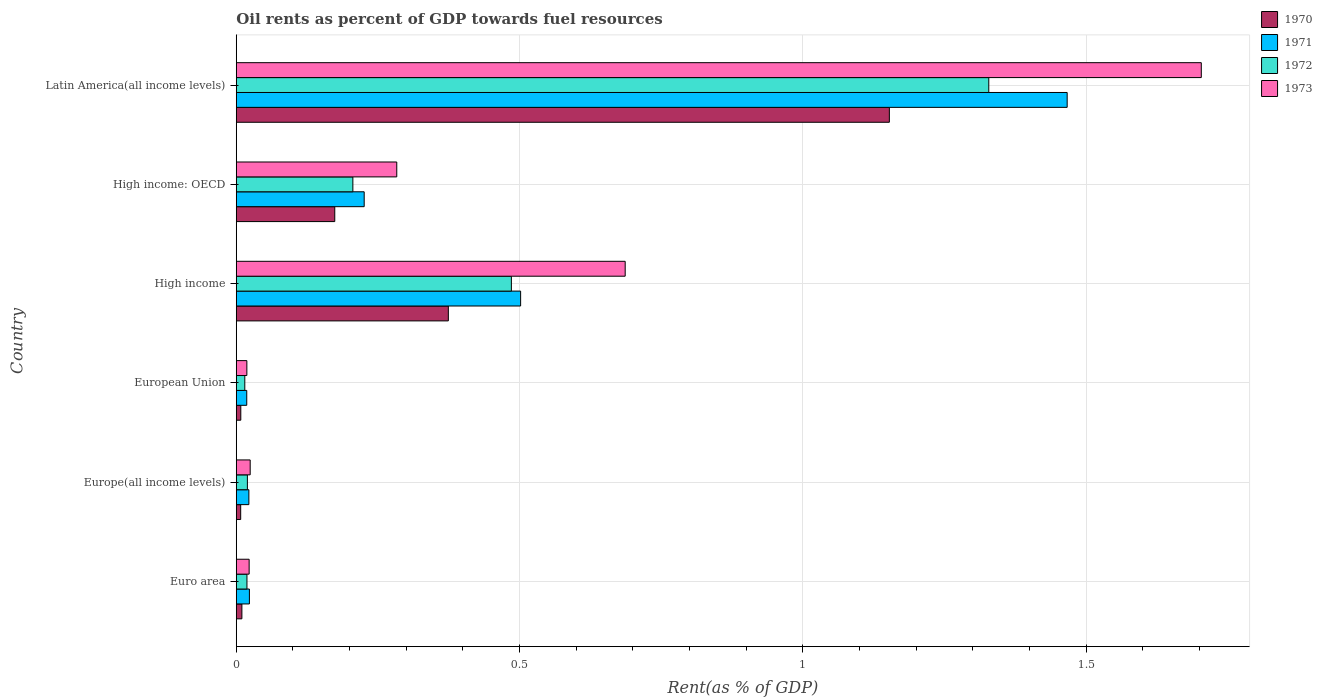Are the number of bars per tick equal to the number of legend labels?
Provide a succinct answer. Yes. How many bars are there on the 1st tick from the bottom?
Offer a terse response. 4. What is the oil rent in 1972 in High income: OECD?
Offer a terse response. 0.21. Across all countries, what is the maximum oil rent in 1971?
Make the answer very short. 1.47. Across all countries, what is the minimum oil rent in 1970?
Ensure brevity in your answer.  0.01. In which country was the oil rent in 1973 maximum?
Give a very brief answer. Latin America(all income levels). In which country was the oil rent in 1971 minimum?
Your answer should be very brief. European Union. What is the total oil rent in 1972 in the graph?
Make the answer very short. 2.07. What is the difference between the oil rent in 1971 in Euro area and that in European Union?
Your response must be concise. 0. What is the difference between the oil rent in 1972 in Euro area and the oil rent in 1971 in High income?
Make the answer very short. -0.48. What is the average oil rent in 1973 per country?
Give a very brief answer. 0.46. What is the difference between the oil rent in 1972 and oil rent in 1970 in High income: OECD?
Make the answer very short. 0.03. What is the ratio of the oil rent in 1971 in High income: OECD to that in Latin America(all income levels)?
Ensure brevity in your answer.  0.15. Is the difference between the oil rent in 1972 in Europe(all income levels) and High income: OECD greater than the difference between the oil rent in 1970 in Europe(all income levels) and High income: OECD?
Give a very brief answer. No. What is the difference between the highest and the second highest oil rent in 1971?
Provide a short and direct response. 0.96. What is the difference between the highest and the lowest oil rent in 1972?
Give a very brief answer. 1.31. Is it the case that in every country, the sum of the oil rent in 1970 and oil rent in 1973 is greater than the sum of oil rent in 1971 and oil rent in 1972?
Ensure brevity in your answer.  No. What does the 3rd bar from the bottom in Latin America(all income levels) represents?
Your answer should be compact. 1972. How many bars are there?
Offer a very short reply. 24. Are all the bars in the graph horizontal?
Your response must be concise. Yes. Are the values on the major ticks of X-axis written in scientific E-notation?
Make the answer very short. No. How many legend labels are there?
Your answer should be very brief. 4. How are the legend labels stacked?
Give a very brief answer. Vertical. What is the title of the graph?
Your answer should be very brief. Oil rents as percent of GDP towards fuel resources. Does "2006" appear as one of the legend labels in the graph?
Ensure brevity in your answer.  No. What is the label or title of the X-axis?
Provide a succinct answer. Rent(as % of GDP). What is the Rent(as % of GDP) of 1970 in Euro area?
Your answer should be compact. 0.01. What is the Rent(as % of GDP) in 1971 in Euro area?
Ensure brevity in your answer.  0.02. What is the Rent(as % of GDP) of 1972 in Euro area?
Make the answer very short. 0.02. What is the Rent(as % of GDP) in 1973 in Euro area?
Your response must be concise. 0.02. What is the Rent(as % of GDP) of 1970 in Europe(all income levels)?
Your answer should be very brief. 0.01. What is the Rent(as % of GDP) in 1971 in Europe(all income levels)?
Provide a succinct answer. 0.02. What is the Rent(as % of GDP) of 1972 in Europe(all income levels)?
Your answer should be compact. 0.02. What is the Rent(as % of GDP) in 1973 in Europe(all income levels)?
Your response must be concise. 0.02. What is the Rent(as % of GDP) of 1970 in European Union?
Ensure brevity in your answer.  0.01. What is the Rent(as % of GDP) of 1971 in European Union?
Give a very brief answer. 0.02. What is the Rent(as % of GDP) of 1972 in European Union?
Offer a very short reply. 0.02. What is the Rent(as % of GDP) in 1973 in European Union?
Your answer should be very brief. 0.02. What is the Rent(as % of GDP) of 1970 in High income?
Offer a very short reply. 0.37. What is the Rent(as % of GDP) of 1971 in High income?
Offer a terse response. 0.5. What is the Rent(as % of GDP) of 1972 in High income?
Ensure brevity in your answer.  0.49. What is the Rent(as % of GDP) of 1973 in High income?
Provide a succinct answer. 0.69. What is the Rent(as % of GDP) in 1970 in High income: OECD?
Offer a very short reply. 0.17. What is the Rent(as % of GDP) of 1971 in High income: OECD?
Your answer should be very brief. 0.23. What is the Rent(as % of GDP) in 1972 in High income: OECD?
Offer a terse response. 0.21. What is the Rent(as % of GDP) of 1973 in High income: OECD?
Your answer should be very brief. 0.28. What is the Rent(as % of GDP) in 1970 in Latin America(all income levels)?
Your answer should be very brief. 1.15. What is the Rent(as % of GDP) in 1971 in Latin America(all income levels)?
Keep it short and to the point. 1.47. What is the Rent(as % of GDP) of 1972 in Latin America(all income levels)?
Make the answer very short. 1.33. What is the Rent(as % of GDP) of 1973 in Latin America(all income levels)?
Keep it short and to the point. 1.7. Across all countries, what is the maximum Rent(as % of GDP) in 1970?
Offer a very short reply. 1.15. Across all countries, what is the maximum Rent(as % of GDP) in 1971?
Your answer should be compact. 1.47. Across all countries, what is the maximum Rent(as % of GDP) in 1972?
Keep it short and to the point. 1.33. Across all countries, what is the maximum Rent(as % of GDP) in 1973?
Your response must be concise. 1.7. Across all countries, what is the minimum Rent(as % of GDP) in 1970?
Your answer should be compact. 0.01. Across all countries, what is the minimum Rent(as % of GDP) of 1971?
Keep it short and to the point. 0.02. Across all countries, what is the minimum Rent(as % of GDP) in 1972?
Offer a terse response. 0.02. Across all countries, what is the minimum Rent(as % of GDP) in 1973?
Offer a very short reply. 0.02. What is the total Rent(as % of GDP) of 1970 in the graph?
Offer a terse response. 1.73. What is the total Rent(as % of GDP) of 1971 in the graph?
Provide a succinct answer. 2.26. What is the total Rent(as % of GDP) of 1972 in the graph?
Offer a very short reply. 2.07. What is the total Rent(as % of GDP) of 1973 in the graph?
Offer a terse response. 2.74. What is the difference between the Rent(as % of GDP) in 1970 in Euro area and that in Europe(all income levels)?
Ensure brevity in your answer.  0. What is the difference between the Rent(as % of GDP) of 1971 in Euro area and that in Europe(all income levels)?
Provide a short and direct response. 0. What is the difference between the Rent(as % of GDP) of 1972 in Euro area and that in Europe(all income levels)?
Give a very brief answer. -0. What is the difference between the Rent(as % of GDP) in 1973 in Euro area and that in Europe(all income levels)?
Offer a terse response. -0. What is the difference between the Rent(as % of GDP) in 1970 in Euro area and that in European Union?
Provide a short and direct response. 0. What is the difference between the Rent(as % of GDP) in 1971 in Euro area and that in European Union?
Give a very brief answer. 0. What is the difference between the Rent(as % of GDP) in 1972 in Euro area and that in European Union?
Offer a very short reply. 0. What is the difference between the Rent(as % of GDP) in 1973 in Euro area and that in European Union?
Provide a succinct answer. 0. What is the difference between the Rent(as % of GDP) of 1970 in Euro area and that in High income?
Provide a short and direct response. -0.36. What is the difference between the Rent(as % of GDP) in 1971 in Euro area and that in High income?
Your answer should be very brief. -0.48. What is the difference between the Rent(as % of GDP) of 1972 in Euro area and that in High income?
Your answer should be very brief. -0.47. What is the difference between the Rent(as % of GDP) of 1973 in Euro area and that in High income?
Your answer should be very brief. -0.66. What is the difference between the Rent(as % of GDP) in 1970 in Euro area and that in High income: OECD?
Provide a succinct answer. -0.16. What is the difference between the Rent(as % of GDP) in 1971 in Euro area and that in High income: OECD?
Offer a very short reply. -0.2. What is the difference between the Rent(as % of GDP) of 1972 in Euro area and that in High income: OECD?
Make the answer very short. -0.19. What is the difference between the Rent(as % of GDP) of 1973 in Euro area and that in High income: OECD?
Your answer should be compact. -0.26. What is the difference between the Rent(as % of GDP) in 1970 in Euro area and that in Latin America(all income levels)?
Offer a very short reply. -1.14. What is the difference between the Rent(as % of GDP) of 1971 in Euro area and that in Latin America(all income levels)?
Ensure brevity in your answer.  -1.44. What is the difference between the Rent(as % of GDP) of 1972 in Euro area and that in Latin America(all income levels)?
Your answer should be compact. -1.31. What is the difference between the Rent(as % of GDP) of 1973 in Euro area and that in Latin America(all income levels)?
Offer a terse response. -1.68. What is the difference between the Rent(as % of GDP) in 1970 in Europe(all income levels) and that in European Union?
Offer a very short reply. -0. What is the difference between the Rent(as % of GDP) in 1971 in Europe(all income levels) and that in European Union?
Offer a terse response. 0. What is the difference between the Rent(as % of GDP) of 1972 in Europe(all income levels) and that in European Union?
Make the answer very short. 0. What is the difference between the Rent(as % of GDP) in 1973 in Europe(all income levels) and that in European Union?
Your answer should be compact. 0.01. What is the difference between the Rent(as % of GDP) in 1970 in Europe(all income levels) and that in High income?
Make the answer very short. -0.37. What is the difference between the Rent(as % of GDP) of 1971 in Europe(all income levels) and that in High income?
Offer a terse response. -0.48. What is the difference between the Rent(as % of GDP) of 1972 in Europe(all income levels) and that in High income?
Your answer should be compact. -0.47. What is the difference between the Rent(as % of GDP) in 1973 in Europe(all income levels) and that in High income?
Your answer should be very brief. -0.66. What is the difference between the Rent(as % of GDP) in 1970 in Europe(all income levels) and that in High income: OECD?
Keep it short and to the point. -0.17. What is the difference between the Rent(as % of GDP) in 1971 in Europe(all income levels) and that in High income: OECD?
Make the answer very short. -0.2. What is the difference between the Rent(as % of GDP) in 1972 in Europe(all income levels) and that in High income: OECD?
Make the answer very short. -0.19. What is the difference between the Rent(as % of GDP) in 1973 in Europe(all income levels) and that in High income: OECD?
Ensure brevity in your answer.  -0.26. What is the difference between the Rent(as % of GDP) of 1970 in Europe(all income levels) and that in Latin America(all income levels)?
Your answer should be very brief. -1.14. What is the difference between the Rent(as % of GDP) in 1971 in Europe(all income levels) and that in Latin America(all income levels)?
Your answer should be compact. -1.44. What is the difference between the Rent(as % of GDP) of 1972 in Europe(all income levels) and that in Latin America(all income levels)?
Offer a terse response. -1.31. What is the difference between the Rent(as % of GDP) in 1973 in Europe(all income levels) and that in Latin America(all income levels)?
Your answer should be very brief. -1.68. What is the difference between the Rent(as % of GDP) of 1970 in European Union and that in High income?
Offer a terse response. -0.37. What is the difference between the Rent(as % of GDP) in 1971 in European Union and that in High income?
Provide a short and direct response. -0.48. What is the difference between the Rent(as % of GDP) in 1972 in European Union and that in High income?
Ensure brevity in your answer.  -0.47. What is the difference between the Rent(as % of GDP) of 1973 in European Union and that in High income?
Make the answer very short. -0.67. What is the difference between the Rent(as % of GDP) in 1970 in European Union and that in High income: OECD?
Your response must be concise. -0.17. What is the difference between the Rent(as % of GDP) in 1971 in European Union and that in High income: OECD?
Make the answer very short. -0.21. What is the difference between the Rent(as % of GDP) in 1972 in European Union and that in High income: OECD?
Ensure brevity in your answer.  -0.19. What is the difference between the Rent(as % of GDP) of 1973 in European Union and that in High income: OECD?
Your answer should be very brief. -0.26. What is the difference between the Rent(as % of GDP) in 1970 in European Union and that in Latin America(all income levels)?
Ensure brevity in your answer.  -1.14. What is the difference between the Rent(as % of GDP) in 1971 in European Union and that in Latin America(all income levels)?
Your response must be concise. -1.45. What is the difference between the Rent(as % of GDP) in 1972 in European Union and that in Latin America(all income levels)?
Make the answer very short. -1.31. What is the difference between the Rent(as % of GDP) in 1973 in European Union and that in Latin America(all income levels)?
Your answer should be very brief. -1.68. What is the difference between the Rent(as % of GDP) of 1970 in High income and that in High income: OECD?
Offer a very short reply. 0.2. What is the difference between the Rent(as % of GDP) of 1971 in High income and that in High income: OECD?
Your answer should be compact. 0.28. What is the difference between the Rent(as % of GDP) in 1972 in High income and that in High income: OECD?
Offer a terse response. 0.28. What is the difference between the Rent(as % of GDP) of 1973 in High income and that in High income: OECD?
Your answer should be compact. 0.4. What is the difference between the Rent(as % of GDP) of 1970 in High income and that in Latin America(all income levels)?
Offer a very short reply. -0.78. What is the difference between the Rent(as % of GDP) of 1971 in High income and that in Latin America(all income levels)?
Offer a terse response. -0.96. What is the difference between the Rent(as % of GDP) in 1972 in High income and that in Latin America(all income levels)?
Give a very brief answer. -0.84. What is the difference between the Rent(as % of GDP) in 1973 in High income and that in Latin America(all income levels)?
Offer a very short reply. -1.02. What is the difference between the Rent(as % of GDP) in 1970 in High income: OECD and that in Latin America(all income levels)?
Offer a very short reply. -0.98. What is the difference between the Rent(as % of GDP) in 1971 in High income: OECD and that in Latin America(all income levels)?
Offer a very short reply. -1.24. What is the difference between the Rent(as % of GDP) of 1972 in High income: OECD and that in Latin America(all income levels)?
Make the answer very short. -1.12. What is the difference between the Rent(as % of GDP) in 1973 in High income: OECD and that in Latin America(all income levels)?
Offer a very short reply. -1.42. What is the difference between the Rent(as % of GDP) of 1970 in Euro area and the Rent(as % of GDP) of 1971 in Europe(all income levels)?
Offer a very short reply. -0.01. What is the difference between the Rent(as % of GDP) in 1970 in Euro area and the Rent(as % of GDP) in 1972 in Europe(all income levels)?
Offer a very short reply. -0.01. What is the difference between the Rent(as % of GDP) in 1970 in Euro area and the Rent(as % of GDP) in 1973 in Europe(all income levels)?
Your answer should be compact. -0.01. What is the difference between the Rent(as % of GDP) in 1971 in Euro area and the Rent(as % of GDP) in 1972 in Europe(all income levels)?
Your response must be concise. 0. What is the difference between the Rent(as % of GDP) of 1971 in Euro area and the Rent(as % of GDP) of 1973 in Europe(all income levels)?
Offer a terse response. -0. What is the difference between the Rent(as % of GDP) of 1972 in Euro area and the Rent(as % of GDP) of 1973 in Europe(all income levels)?
Offer a very short reply. -0.01. What is the difference between the Rent(as % of GDP) in 1970 in Euro area and the Rent(as % of GDP) in 1971 in European Union?
Offer a very short reply. -0.01. What is the difference between the Rent(as % of GDP) of 1970 in Euro area and the Rent(as % of GDP) of 1972 in European Union?
Make the answer very short. -0.01. What is the difference between the Rent(as % of GDP) of 1970 in Euro area and the Rent(as % of GDP) of 1973 in European Union?
Your response must be concise. -0.01. What is the difference between the Rent(as % of GDP) in 1971 in Euro area and the Rent(as % of GDP) in 1972 in European Union?
Your response must be concise. 0.01. What is the difference between the Rent(as % of GDP) of 1971 in Euro area and the Rent(as % of GDP) of 1973 in European Union?
Offer a very short reply. 0. What is the difference between the Rent(as % of GDP) in 1970 in Euro area and the Rent(as % of GDP) in 1971 in High income?
Your answer should be very brief. -0.49. What is the difference between the Rent(as % of GDP) of 1970 in Euro area and the Rent(as % of GDP) of 1972 in High income?
Your response must be concise. -0.48. What is the difference between the Rent(as % of GDP) in 1970 in Euro area and the Rent(as % of GDP) in 1973 in High income?
Keep it short and to the point. -0.68. What is the difference between the Rent(as % of GDP) of 1971 in Euro area and the Rent(as % of GDP) of 1972 in High income?
Your response must be concise. -0.46. What is the difference between the Rent(as % of GDP) of 1971 in Euro area and the Rent(as % of GDP) of 1973 in High income?
Your response must be concise. -0.66. What is the difference between the Rent(as % of GDP) in 1972 in Euro area and the Rent(as % of GDP) in 1973 in High income?
Give a very brief answer. -0.67. What is the difference between the Rent(as % of GDP) of 1970 in Euro area and the Rent(as % of GDP) of 1971 in High income: OECD?
Offer a very short reply. -0.22. What is the difference between the Rent(as % of GDP) of 1970 in Euro area and the Rent(as % of GDP) of 1972 in High income: OECD?
Offer a terse response. -0.2. What is the difference between the Rent(as % of GDP) of 1970 in Euro area and the Rent(as % of GDP) of 1973 in High income: OECD?
Make the answer very short. -0.27. What is the difference between the Rent(as % of GDP) in 1971 in Euro area and the Rent(as % of GDP) in 1972 in High income: OECD?
Your answer should be very brief. -0.18. What is the difference between the Rent(as % of GDP) of 1971 in Euro area and the Rent(as % of GDP) of 1973 in High income: OECD?
Offer a terse response. -0.26. What is the difference between the Rent(as % of GDP) of 1972 in Euro area and the Rent(as % of GDP) of 1973 in High income: OECD?
Ensure brevity in your answer.  -0.26. What is the difference between the Rent(as % of GDP) of 1970 in Euro area and the Rent(as % of GDP) of 1971 in Latin America(all income levels)?
Your answer should be very brief. -1.46. What is the difference between the Rent(as % of GDP) in 1970 in Euro area and the Rent(as % of GDP) in 1972 in Latin America(all income levels)?
Provide a short and direct response. -1.32. What is the difference between the Rent(as % of GDP) of 1970 in Euro area and the Rent(as % of GDP) of 1973 in Latin America(all income levels)?
Offer a very short reply. -1.69. What is the difference between the Rent(as % of GDP) of 1971 in Euro area and the Rent(as % of GDP) of 1972 in Latin America(all income levels)?
Your answer should be compact. -1.3. What is the difference between the Rent(as % of GDP) in 1971 in Euro area and the Rent(as % of GDP) in 1973 in Latin America(all income levels)?
Offer a very short reply. -1.68. What is the difference between the Rent(as % of GDP) in 1972 in Euro area and the Rent(as % of GDP) in 1973 in Latin America(all income levels)?
Your response must be concise. -1.68. What is the difference between the Rent(as % of GDP) in 1970 in Europe(all income levels) and the Rent(as % of GDP) in 1971 in European Union?
Your response must be concise. -0.01. What is the difference between the Rent(as % of GDP) in 1970 in Europe(all income levels) and the Rent(as % of GDP) in 1972 in European Union?
Make the answer very short. -0.01. What is the difference between the Rent(as % of GDP) in 1970 in Europe(all income levels) and the Rent(as % of GDP) in 1973 in European Union?
Keep it short and to the point. -0.01. What is the difference between the Rent(as % of GDP) of 1971 in Europe(all income levels) and the Rent(as % of GDP) of 1972 in European Union?
Your answer should be compact. 0.01. What is the difference between the Rent(as % of GDP) of 1971 in Europe(all income levels) and the Rent(as % of GDP) of 1973 in European Union?
Give a very brief answer. 0. What is the difference between the Rent(as % of GDP) in 1972 in Europe(all income levels) and the Rent(as % of GDP) in 1973 in European Union?
Offer a very short reply. 0. What is the difference between the Rent(as % of GDP) in 1970 in Europe(all income levels) and the Rent(as % of GDP) in 1971 in High income?
Your answer should be very brief. -0.49. What is the difference between the Rent(as % of GDP) of 1970 in Europe(all income levels) and the Rent(as % of GDP) of 1972 in High income?
Your response must be concise. -0.48. What is the difference between the Rent(as % of GDP) of 1970 in Europe(all income levels) and the Rent(as % of GDP) of 1973 in High income?
Offer a very short reply. -0.68. What is the difference between the Rent(as % of GDP) of 1971 in Europe(all income levels) and the Rent(as % of GDP) of 1972 in High income?
Offer a very short reply. -0.46. What is the difference between the Rent(as % of GDP) of 1971 in Europe(all income levels) and the Rent(as % of GDP) of 1973 in High income?
Provide a short and direct response. -0.66. What is the difference between the Rent(as % of GDP) in 1972 in Europe(all income levels) and the Rent(as % of GDP) in 1973 in High income?
Make the answer very short. -0.67. What is the difference between the Rent(as % of GDP) in 1970 in Europe(all income levels) and the Rent(as % of GDP) in 1971 in High income: OECD?
Your answer should be very brief. -0.22. What is the difference between the Rent(as % of GDP) of 1970 in Europe(all income levels) and the Rent(as % of GDP) of 1972 in High income: OECD?
Your answer should be very brief. -0.2. What is the difference between the Rent(as % of GDP) of 1970 in Europe(all income levels) and the Rent(as % of GDP) of 1973 in High income: OECD?
Provide a short and direct response. -0.28. What is the difference between the Rent(as % of GDP) in 1971 in Europe(all income levels) and the Rent(as % of GDP) in 1972 in High income: OECD?
Give a very brief answer. -0.18. What is the difference between the Rent(as % of GDP) in 1971 in Europe(all income levels) and the Rent(as % of GDP) in 1973 in High income: OECD?
Give a very brief answer. -0.26. What is the difference between the Rent(as % of GDP) in 1972 in Europe(all income levels) and the Rent(as % of GDP) in 1973 in High income: OECD?
Your response must be concise. -0.26. What is the difference between the Rent(as % of GDP) of 1970 in Europe(all income levels) and the Rent(as % of GDP) of 1971 in Latin America(all income levels)?
Keep it short and to the point. -1.46. What is the difference between the Rent(as % of GDP) of 1970 in Europe(all income levels) and the Rent(as % of GDP) of 1972 in Latin America(all income levels)?
Provide a succinct answer. -1.32. What is the difference between the Rent(as % of GDP) in 1970 in Europe(all income levels) and the Rent(as % of GDP) in 1973 in Latin America(all income levels)?
Offer a terse response. -1.7. What is the difference between the Rent(as % of GDP) in 1971 in Europe(all income levels) and the Rent(as % of GDP) in 1972 in Latin America(all income levels)?
Provide a short and direct response. -1.31. What is the difference between the Rent(as % of GDP) in 1971 in Europe(all income levels) and the Rent(as % of GDP) in 1973 in Latin America(all income levels)?
Your response must be concise. -1.68. What is the difference between the Rent(as % of GDP) of 1972 in Europe(all income levels) and the Rent(as % of GDP) of 1973 in Latin America(all income levels)?
Your answer should be very brief. -1.68. What is the difference between the Rent(as % of GDP) in 1970 in European Union and the Rent(as % of GDP) in 1971 in High income?
Keep it short and to the point. -0.49. What is the difference between the Rent(as % of GDP) of 1970 in European Union and the Rent(as % of GDP) of 1972 in High income?
Provide a succinct answer. -0.48. What is the difference between the Rent(as % of GDP) of 1970 in European Union and the Rent(as % of GDP) of 1973 in High income?
Offer a very short reply. -0.68. What is the difference between the Rent(as % of GDP) of 1971 in European Union and the Rent(as % of GDP) of 1972 in High income?
Your response must be concise. -0.47. What is the difference between the Rent(as % of GDP) in 1971 in European Union and the Rent(as % of GDP) in 1973 in High income?
Give a very brief answer. -0.67. What is the difference between the Rent(as % of GDP) in 1972 in European Union and the Rent(as % of GDP) in 1973 in High income?
Make the answer very short. -0.67. What is the difference between the Rent(as % of GDP) of 1970 in European Union and the Rent(as % of GDP) of 1971 in High income: OECD?
Your response must be concise. -0.22. What is the difference between the Rent(as % of GDP) in 1970 in European Union and the Rent(as % of GDP) in 1972 in High income: OECD?
Keep it short and to the point. -0.2. What is the difference between the Rent(as % of GDP) in 1970 in European Union and the Rent(as % of GDP) in 1973 in High income: OECD?
Ensure brevity in your answer.  -0.28. What is the difference between the Rent(as % of GDP) of 1971 in European Union and the Rent(as % of GDP) of 1972 in High income: OECD?
Provide a succinct answer. -0.19. What is the difference between the Rent(as % of GDP) in 1971 in European Union and the Rent(as % of GDP) in 1973 in High income: OECD?
Your answer should be compact. -0.26. What is the difference between the Rent(as % of GDP) of 1972 in European Union and the Rent(as % of GDP) of 1973 in High income: OECD?
Provide a succinct answer. -0.27. What is the difference between the Rent(as % of GDP) in 1970 in European Union and the Rent(as % of GDP) in 1971 in Latin America(all income levels)?
Offer a terse response. -1.46. What is the difference between the Rent(as % of GDP) of 1970 in European Union and the Rent(as % of GDP) of 1972 in Latin America(all income levels)?
Ensure brevity in your answer.  -1.32. What is the difference between the Rent(as % of GDP) of 1970 in European Union and the Rent(as % of GDP) of 1973 in Latin America(all income levels)?
Provide a short and direct response. -1.7. What is the difference between the Rent(as % of GDP) of 1971 in European Union and the Rent(as % of GDP) of 1972 in Latin America(all income levels)?
Your answer should be compact. -1.31. What is the difference between the Rent(as % of GDP) in 1971 in European Union and the Rent(as % of GDP) in 1973 in Latin America(all income levels)?
Give a very brief answer. -1.68. What is the difference between the Rent(as % of GDP) of 1972 in European Union and the Rent(as % of GDP) of 1973 in Latin America(all income levels)?
Ensure brevity in your answer.  -1.69. What is the difference between the Rent(as % of GDP) in 1970 in High income and the Rent(as % of GDP) in 1971 in High income: OECD?
Provide a succinct answer. 0.15. What is the difference between the Rent(as % of GDP) of 1970 in High income and the Rent(as % of GDP) of 1972 in High income: OECD?
Your answer should be compact. 0.17. What is the difference between the Rent(as % of GDP) in 1970 in High income and the Rent(as % of GDP) in 1973 in High income: OECD?
Provide a short and direct response. 0.09. What is the difference between the Rent(as % of GDP) of 1971 in High income and the Rent(as % of GDP) of 1972 in High income: OECD?
Make the answer very short. 0.3. What is the difference between the Rent(as % of GDP) in 1971 in High income and the Rent(as % of GDP) in 1973 in High income: OECD?
Keep it short and to the point. 0.22. What is the difference between the Rent(as % of GDP) in 1972 in High income and the Rent(as % of GDP) in 1973 in High income: OECD?
Offer a very short reply. 0.2. What is the difference between the Rent(as % of GDP) in 1970 in High income and the Rent(as % of GDP) in 1971 in Latin America(all income levels)?
Your answer should be very brief. -1.09. What is the difference between the Rent(as % of GDP) of 1970 in High income and the Rent(as % of GDP) of 1972 in Latin America(all income levels)?
Provide a succinct answer. -0.95. What is the difference between the Rent(as % of GDP) in 1970 in High income and the Rent(as % of GDP) in 1973 in Latin America(all income levels)?
Offer a very short reply. -1.33. What is the difference between the Rent(as % of GDP) in 1971 in High income and the Rent(as % of GDP) in 1972 in Latin America(all income levels)?
Provide a short and direct response. -0.83. What is the difference between the Rent(as % of GDP) in 1971 in High income and the Rent(as % of GDP) in 1973 in Latin America(all income levels)?
Keep it short and to the point. -1.2. What is the difference between the Rent(as % of GDP) of 1972 in High income and the Rent(as % of GDP) of 1973 in Latin America(all income levels)?
Offer a very short reply. -1.22. What is the difference between the Rent(as % of GDP) of 1970 in High income: OECD and the Rent(as % of GDP) of 1971 in Latin America(all income levels)?
Give a very brief answer. -1.29. What is the difference between the Rent(as % of GDP) of 1970 in High income: OECD and the Rent(as % of GDP) of 1972 in Latin America(all income levels)?
Your answer should be compact. -1.15. What is the difference between the Rent(as % of GDP) in 1970 in High income: OECD and the Rent(as % of GDP) in 1973 in Latin America(all income levels)?
Provide a succinct answer. -1.53. What is the difference between the Rent(as % of GDP) of 1971 in High income: OECD and the Rent(as % of GDP) of 1972 in Latin America(all income levels)?
Give a very brief answer. -1.1. What is the difference between the Rent(as % of GDP) of 1971 in High income: OECD and the Rent(as % of GDP) of 1973 in Latin America(all income levels)?
Your answer should be very brief. -1.48. What is the difference between the Rent(as % of GDP) of 1972 in High income: OECD and the Rent(as % of GDP) of 1973 in Latin America(all income levels)?
Your answer should be very brief. -1.5. What is the average Rent(as % of GDP) of 1970 per country?
Offer a very short reply. 0.29. What is the average Rent(as % of GDP) of 1971 per country?
Give a very brief answer. 0.38. What is the average Rent(as % of GDP) of 1972 per country?
Provide a short and direct response. 0.35. What is the average Rent(as % of GDP) of 1973 per country?
Ensure brevity in your answer.  0.46. What is the difference between the Rent(as % of GDP) in 1970 and Rent(as % of GDP) in 1971 in Euro area?
Your response must be concise. -0.01. What is the difference between the Rent(as % of GDP) in 1970 and Rent(as % of GDP) in 1972 in Euro area?
Offer a very short reply. -0.01. What is the difference between the Rent(as % of GDP) of 1970 and Rent(as % of GDP) of 1973 in Euro area?
Make the answer very short. -0.01. What is the difference between the Rent(as % of GDP) of 1971 and Rent(as % of GDP) of 1972 in Euro area?
Make the answer very short. 0. What is the difference between the Rent(as % of GDP) of 1971 and Rent(as % of GDP) of 1973 in Euro area?
Make the answer very short. 0. What is the difference between the Rent(as % of GDP) in 1972 and Rent(as % of GDP) in 1973 in Euro area?
Your response must be concise. -0. What is the difference between the Rent(as % of GDP) in 1970 and Rent(as % of GDP) in 1971 in Europe(all income levels)?
Your answer should be very brief. -0.01. What is the difference between the Rent(as % of GDP) of 1970 and Rent(as % of GDP) of 1972 in Europe(all income levels)?
Offer a very short reply. -0.01. What is the difference between the Rent(as % of GDP) of 1970 and Rent(as % of GDP) of 1973 in Europe(all income levels)?
Provide a short and direct response. -0.02. What is the difference between the Rent(as % of GDP) of 1971 and Rent(as % of GDP) of 1972 in Europe(all income levels)?
Your response must be concise. 0. What is the difference between the Rent(as % of GDP) of 1971 and Rent(as % of GDP) of 1973 in Europe(all income levels)?
Your answer should be very brief. -0. What is the difference between the Rent(as % of GDP) of 1972 and Rent(as % of GDP) of 1973 in Europe(all income levels)?
Your response must be concise. -0.01. What is the difference between the Rent(as % of GDP) of 1970 and Rent(as % of GDP) of 1971 in European Union?
Give a very brief answer. -0.01. What is the difference between the Rent(as % of GDP) of 1970 and Rent(as % of GDP) of 1972 in European Union?
Your response must be concise. -0.01. What is the difference between the Rent(as % of GDP) in 1970 and Rent(as % of GDP) in 1973 in European Union?
Your response must be concise. -0.01. What is the difference between the Rent(as % of GDP) of 1971 and Rent(as % of GDP) of 1972 in European Union?
Your answer should be compact. 0. What is the difference between the Rent(as % of GDP) in 1971 and Rent(as % of GDP) in 1973 in European Union?
Your answer should be compact. -0. What is the difference between the Rent(as % of GDP) in 1972 and Rent(as % of GDP) in 1973 in European Union?
Keep it short and to the point. -0. What is the difference between the Rent(as % of GDP) in 1970 and Rent(as % of GDP) in 1971 in High income?
Your answer should be very brief. -0.13. What is the difference between the Rent(as % of GDP) of 1970 and Rent(as % of GDP) of 1972 in High income?
Offer a terse response. -0.11. What is the difference between the Rent(as % of GDP) in 1970 and Rent(as % of GDP) in 1973 in High income?
Keep it short and to the point. -0.31. What is the difference between the Rent(as % of GDP) in 1971 and Rent(as % of GDP) in 1972 in High income?
Offer a very short reply. 0.02. What is the difference between the Rent(as % of GDP) in 1971 and Rent(as % of GDP) in 1973 in High income?
Keep it short and to the point. -0.18. What is the difference between the Rent(as % of GDP) in 1972 and Rent(as % of GDP) in 1973 in High income?
Offer a terse response. -0.2. What is the difference between the Rent(as % of GDP) in 1970 and Rent(as % of GDP) in 1971 in High income: OECD?
Keep it short and to the point. -0.05. What is the difference between the Rent(as % of GDP) in 1970 and Rent(as % of GDP) in 1972 in High income: OECD?
Keep it short and to the point. -0.03. What is the difference between the Rent(as % of GDP) in 1970 and Rent(as % of GDP) in 1973 in High income: OECD?
Offer a terse response. -0.11. What is the difference between the Rent(as % of GDP) of 1971 and Rent(as % of GDP) of 1973 in High income: OECD?
Make the answer very short. -0.06. What is the difference between the Rent(as % of GDP) in 1972 and Rent(as % of GDP) in 1973 in High income: OECD?
Offer a very short reply. -0.08. What is the difference between the Rent(as % of GDP) in 1970 and Rent(as % of GDP) in 1971 in Latin America(all income levels)?
Give a very brief answer. -0.31. What is the difference between the Rent(as % of GDP) in 1970 and Rent(as % of GDP) in 1972 in Latin America(all income levels)?
Make the answer very short. -0.18. What is the difference between the Rent(as % of GDP) of 1970 and Rent(as % of GDP) of 1973 in Latin America(all income levels)?
Give a very brief answer. -0.55. What is the difference between the Rent(as % of GDP) of 1971 and Rent(as % of GDP) of 1972 in Latin America(all income levels)?
Your answer should be compact. 0.14. What is the difference between the Rent(as % of GDP) of 1971 and Rent(as % of GDP) of 1973 in Latin America(all income levels)?
Keep it short and to the point. -0.24. What is the difference between the Rent(as % of GDP) in 1972 and Rent(as % of GDP) in 1973 in Latin America(all income levels)?
Offer a very short reply. -0.38. What is the ratio of the Rent(as % of GDP) in 1970 in Euro area to that in Europe(all income levels)?
Make the answer very short. 1.27. What is the ratio of the Rent(as % of GDP) in 1971 in Euro area to that in Europe(all income levels)?
Ensure brevity in your answer.  1.04. What is the ratio of the Rent(as % of GDP) in 1972 in Euro area to that in Europe(all income levels)?
Keep it short and to the point. 0.96. What is the ratio of the Rent(as % of GDP) in 1973 in Euro area to that in Europe(all income levels)?
Your answer should be compact. 0.92. What is the ratio of the Rent(as % of GDP) in 1970 in Euro area to that in European Union?
Your answer should be compact. 1.24. What is the ratio of the Rent(as % of GDP) of 1971 in Euro area to that in European Union?
Offer a very short reply. 1.25. What is the ratio of the Rent(as % of GDP) of 1972 in Euro area to that in European Union?
Give a very brief answer. 1.25. What is the ratio of the Rent(as % of GDP) of 1973 in Euro area to that in European Union?
Ensure brevity in your answer.  1.22. What is the ratio of the Rent(as % of GDP) in 1970 in Euro area to that in High income?
Offer a very short reply. 0.03. What is the ratio of the Rent(as % of GDP) in 1971 in Euro area to that in High income?
Offer a terse response. 0.05. What is the ratio of the Rent(as % of GDP) in 1972 in Euro area to that in High income?
Ensure brevity in your answer.  0.04. What is the ratio of the Rent(as % of GDP) of 1973 in Euro area to that in High income?
Provide a short and direct response. 0.03. What is the ratio of the Rent(as % of GDP) of 1970 in Euro area to that in High income: OECD?
Your answer should be compact. 0.06. What is the ratio of the Rent(as % of GDP) of 1971 in Euro area to that in High income: OECD?
Your answer should be compact. 0.1. What is the ratio of the Rent(as % of GDP) of 1972 in Euro area to that in High income: OECD?
Offer a terse response. 0.09. What is the ratio of the Rent(as % of GDP) of 1973 in Euro area to that in High income: OECD?
Provide a succinct answer. 0.08. What is the ratio of the Rent(as % of GDP) in 1970 in Euro area to that in Latin America(all income levels)?
Provide a succinct answer. 0.01. What is the ratio of the Rent(as % of GDP) in 1971 in Euro area to that in Latin America(all income levels)?
Give a very brief answer. 0.02. What is the ratio of the Rent(as % of GDP) of 1972 in Euro area to that in Latin America(all income levels)?
Provide a short and direct response. 0.01. What is the ratio of the Rent(as % of GDP) in 1973 in Euro area to that in Latin America(all income levels)?
Give a very brief answer. 0.01. What is the ratio of the Rent(as % of GDP) in 1970 in Europe(all income levels) to that in European Union?
Your response must be concise. 0.98. What is the ratio of the Rent(as % of GDP) in 1971 in Europe(all income levels) to that in European Union?
Offer a very short reply. 1.2. What is the ratio of the Rent(as % of GDP) in 1972 in Europe(all income levels) to that in European Union?
Provide a short and direct response. 1.3. What is the ratio of the Rent(as % of GDP) of 1973 in Europe(all income levels) to that in European Union?
Your response must be concise. 1.31. What is the ratio of the Rent(as % of GDP) of 1970 in Europe(all income levels) to that in High income?
Your answer should be compact. 0.02. What is the ratio of the Rent(as % of GDP) in 1971 in Europe(all income levels) to that in High income?
Give a very brief answer. 0.04. What is the ratio of the Rent(as % of GDP) in 1972 in Europe(all income levels) to that in High income?
Offer a very short reply. 0.04. What is the ratio of the Rent(as % of GDP) of 1973 in Europe(all income levels) to that in High income?
Keep it short and to the point. 0.04. What is the ratio of the Rent(as % of GDP) in 1970 in Europe(all income levels) to that in High income: OECD?
Offer a terse response. 0.05. What is the ratio of the Rent(as % of GDP) of 1971 in Europe(all income levels) to that in High income: OECD?
Offer a very short reply. 0.1. What is the ratio of the Rent(as % of GDP) in 1972 in Europe(all income levels) to that in High income: OECD?
Your answer should be very brief. 0.1. What is the ratio of the Rent(as % of GDP) in 1973 in Europe(all income levels) to that in High income: OECD?
Provide a short and direct response. 0.09. What is the ratio of the Rent(as % of GDP) of 1970 in Europe(all income levels) to that in Latin America(all income levels)?
Give a very brief answer. 0.01. What is the ratio of the Rent(as % of GDP) of 1971 in Europe(all income levels) to that in Latin America(all income levels)?
Keep it short and to the point. 0.02. What is the ratio of the Rent(as % of GDP) in 1972 in Europe(all income levels) to that in Latin America(all income levels)?
Keep it short and to the point. 0.01. What is the ratio of the Rent(as % of GDP) of 1973 in Europe(all income levels) to that in Latin America(all income levels)?
Offer a very short reply. 0.01. What is the ratio of the Rent(as % of GDP) in 1970 in European Union to that in High income?
Give a very brief answer. 0.02. What is the ratio of the Rent(as % of GDP) in 1971 in European Union to that in High income?
Ensure brevity in your answer.  0.04. What is the ratio of the Rent(as % of GDP) in 1972 in European Union to that in High income?
Provide a short and direct response. 0.03. What is the ratio of the Rent(as % of GDP) of 1973 in European Union to that in High income?
Keep it short and to the point. 0.03. What is the ratio of the Rent(as % of GDP) of 1970 in European Union to that in High income: OECD?
Your answer should be compact. 0.05. What is the ratio of the Rent(as % of GDP) of 1971 in European Union to that in High income: OECD?
Keep it short and to the point. 0.08. What is the ratio of the Rent(as % of GDP) of 1972 in European Union to that in High income: OECD?
Your response must be concise. 0.07. What is the ratio of the Rent(as % of GDP) of 1973 in European Union to that in High income: OECD?
Ensure brevity in your answer.  0.07. What is the ratio of the Rent(as % of GDP) in 1970 in European Union to that in Latin America(all income levels)?
Your response must be concise. 0.01. What is the ratio of the Rent(as % of GDP) of 1971 in European Union to that in Latin America(all income levels)?
Provide a succinct answer. 0.01. What is the ratio of the Rent(as % of GDP) of 1972 in European Union to that in Latin America(all income levels)?
Offer a terse response. 0.01. What is the ratio of the Rent(as % of GDP) in 1973 in European Union to that in Latin America(all income levels)?
Provide a short and direct response. 0.01. What is the ratio of the Rent(as % of GDP) in 1970 in High income to that in High income: OECD?
Your answer should be compact. 2.15. What is the ratio of the Rent(as % of GDP) of 1971 in High income to that in High income: OECD?
Offer a very short reply. 2.22. What is the ratio of the Rent(as % of GDP) in 1972 in High income to that in High income: OECD?
Keep it short and to the point. 2.36. What is the ratio of the Rent(as % of GDP) in 1973 in High income to that in High income: OECD?
Offer a very short reply. 2.42. What is the ratio of the Rent(as % of GDP) in 1970 in High income to that in Latin America(all income levels)?
Provide a succinct answer. 0.32. What is the ratio of the Rent(as % of GDP) in 1971 in High income to that in Latin America(all income levels)?
Provide a succinct answer. 0.34. What is the ratio of the Rent(as % of GDP) in 1972 in High income to that in Latin America(all income levels)?
Provide a short and direct response. 0.37. What is the ratio of the Rent(as % of GDP) of 1973 in High income to that in Latin America(all income levels)?
Provide a succinct answer. 0.4. What is the ratio of the Rent(as % of GDP) in 1970 in High income: OECD to that in Latin America(all income levels)?
Give a very brief answer. 0.15. What is the ratio of the Rent(as % of GDP) in 1971 in High income: OECD to that in Latin America(all income levels)?
Give a very brief answer. 0.15. What is the ratio of the Rent(as % of GDP) of 1972 in High income: OECD to that in Latin America(all income levels)?
Offer a very short reply. 0.15. What is the ratio of the Rent(as % of GDP) in 1973 in High income: OECD to that in Latin America(all income levels)?
Your answer should be compact. 0.17. What is the difference between the highest and the second highest Rent(as % of GDP) in 1970?
Your response must be concise. 0.78. What is the difference between the highest and the second highest Rent(as % of GDP) in 1971?
Keep it short and to the point. 0.96. What is the difference between the highest and the second highest Rent(as % of GDP) of 1972?
Offer a terse response. 0.84. What is the difference between the highest and the second highest Rent(as % of GDP) of 1973?
Make the answer very short. 1.02. What is the difference between the highest and the lowest Rent(as % of GDP) of 1970?
Your response must be concise. 1.14. What is the difference between the highest and the lowest Rent(as % of GDP) of 1971?
Provide a succinct answer. 1.45. What is the difference between the highest and the lowest Rent(as % of GDP) in 1972?
Give a very brief answer. 1.31. What is the difference between the highest and the lowest Rent(as % of GDP) of 1973?
Keep it short and to the point. 1.68. 